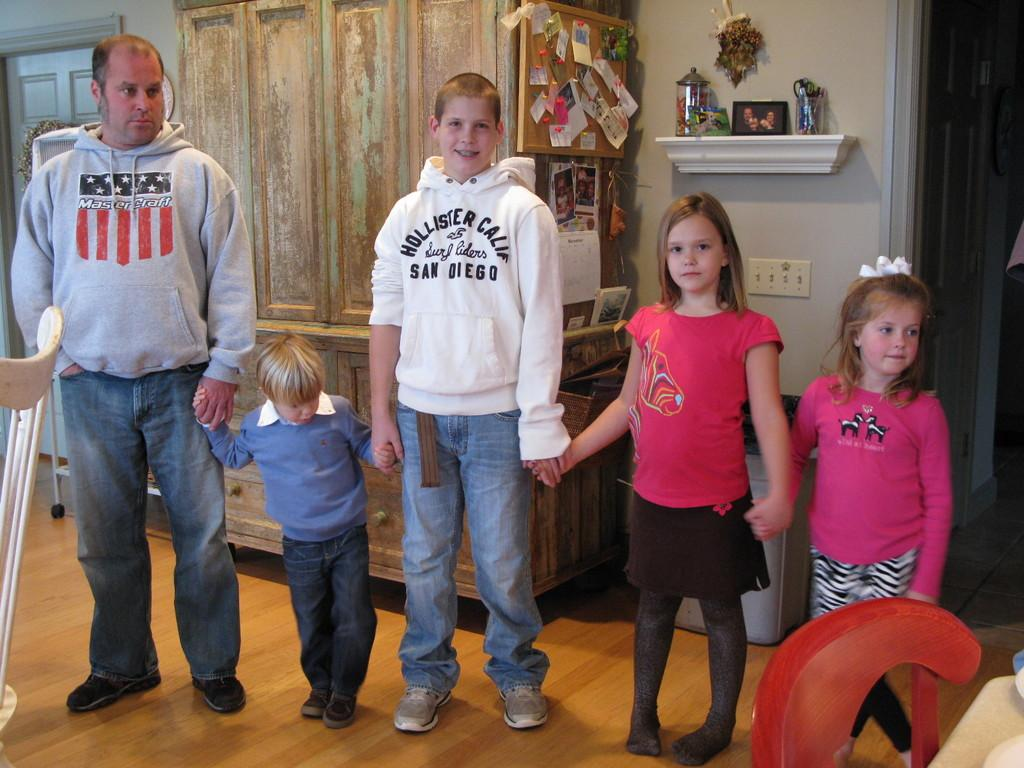What are the people in the image doing? The persons standing on the floor in the image are likely engaged in some activity or standing still. What can be seen in the background of the image? There is a cupboard in the background of the image. What is visible beneath the people's feet in the image? The floor is visible in the image. What is the primary architectural feature in the image? There is a wall in the image. What type of hen can be seen sitting on the wall in the image? There is no hen present in the image; only the persons, floor, cupboard, and wall are visible. 